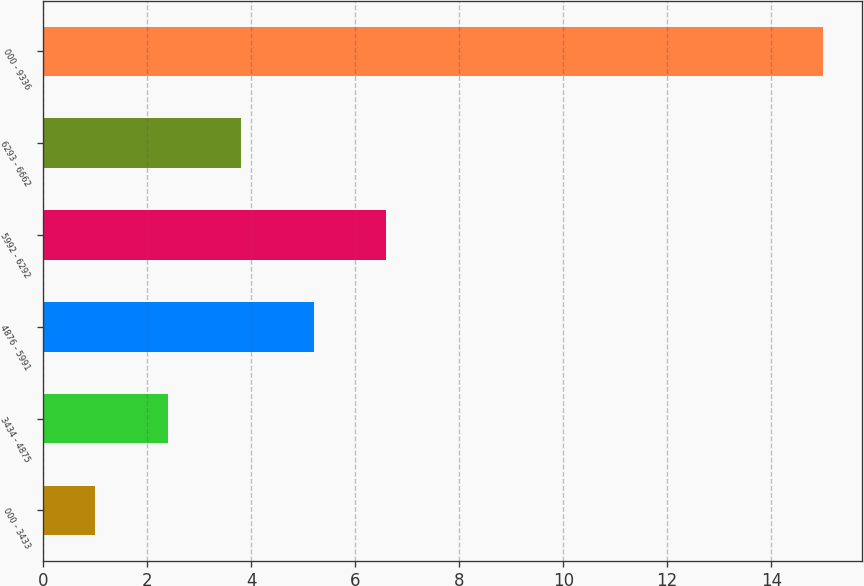<chart> <loc_0><loc_0><loc_500><loc_500><bar_chart><fcel>000 - 3433<fcel>3434 - 4875<fcel>4876 - 5991<fcel>5992 - 6292<fcel>6293 - 6662<fcel>000 - 9336<nl><fcel>1<fcel>2.4<fcel>5.2<fcel>6.6<fcel>3.8<fcel>15<nl></chart> 